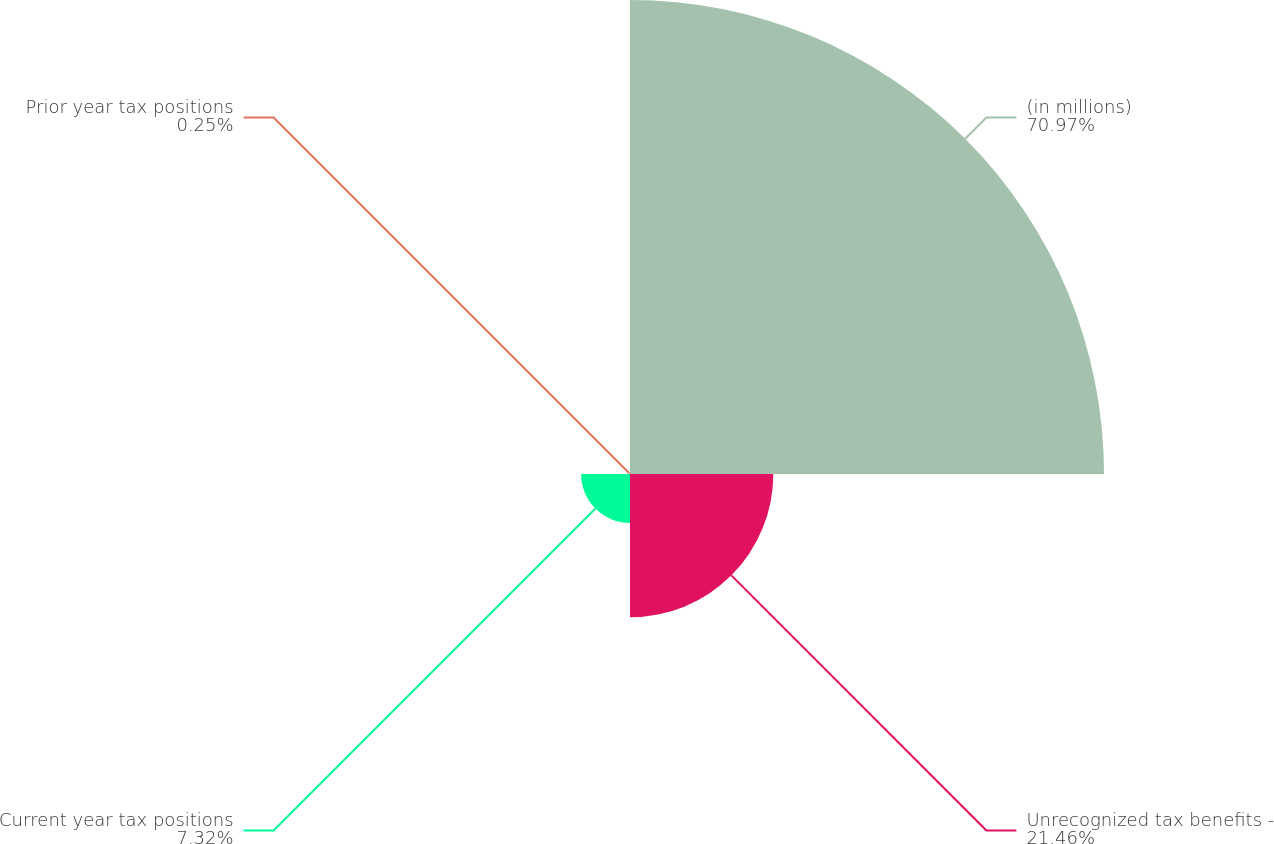Convert chart. <chart><loc_0><loc_0><loc_500><loc_500><pie_chart><fcel>(in millions)<fcel>Unrecognized tax benefits -<fcel>Current year tax positions<fcel>Prior year tax positions<nl><fcel>70.97%<fcel>21.46%<fcel>7.32%<fcel>0.25%<nl></chart> 